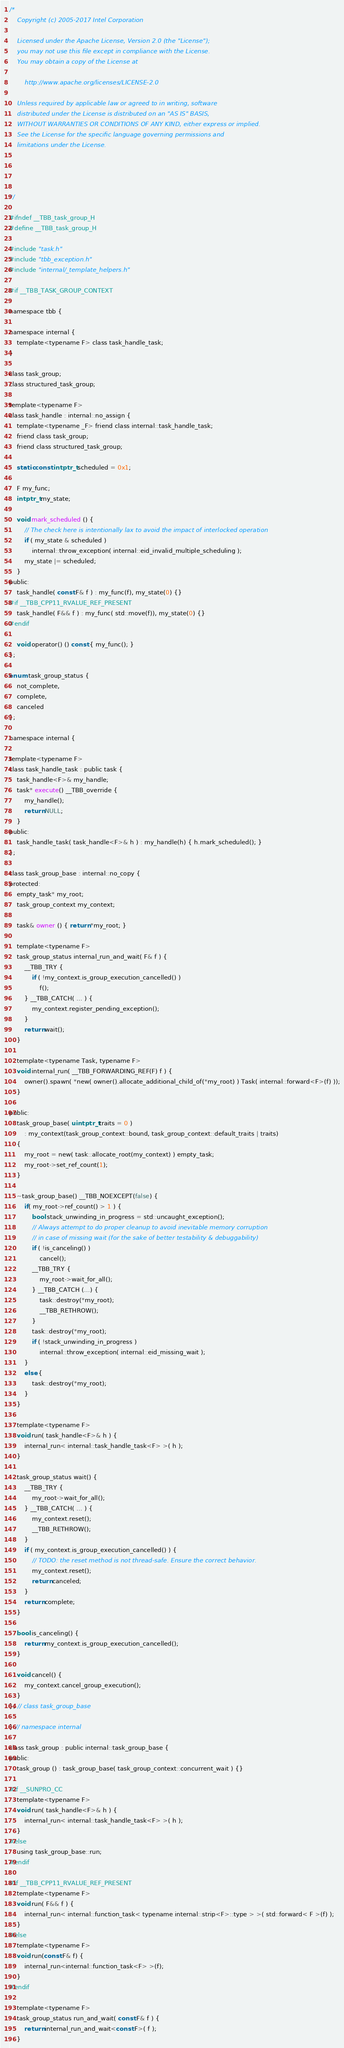Convert code to text. <code><loc_0><loc_0><loc_500><loc_500><_C_>/*
    Copyright (c) 2005-2017 Intel Corporation

    Licensed under the Apache License, Version 2.0 (the "License");
    you may not use this file except in compliance with the License.
    You may obtain a copy of the License at

        http://www.apache.org/licenses/LICENSE-2.0

    Unless required by applicable law or agreed to in writing, software
    distributed under the License is distributed on an "AS IS" BASIS,
    WITHOUT WARRANTIES OR CONDITIONS OF ANY KIND, either express or implied.
    See the License for the specific language governing permissions and
    limitations under the License.




*/

#ifndef __TBB_task_group_H
#define __TBB_task_group_H

#include "task.h"
#include "tbb_exception.h"
#include "internal/_template_helpers.h"

#if __TBB_TASK_GROUP_CONTEXT

namespace tbb {

namespace internal {
    template<typename F> class task_handle_task;
}

class task_group;
class structured_task_group;

template<typename F>
class task_handle : internal::no_assign {
    template<typename _F> friend class internal::task_handle_task;
    friend class task_group;
    friend class structured_task_group;

    static const intptr_t scheduled = 0x1;

    F my_func;
    intptr_t my_state;

    void mark_scheduled () {
        // The check here is intentionally lax to avoid the impact of interlocked operation
        if ( my_state & scheduled )
            internal::throw_exception( internal::eid_invalid_multiple_scheduling );
        my_state |= scheduled;
    }
public:
    task_handle( const F& f ) : my_func(f), my_state(0) {}
#if __TBB_CPP11_RVALUE_REF_PRESENT
    task_handle( F&& f ) : my_func( std::move(f)), my_state(0) {}
#endif

    void operator() () const { my_func(); }
};

enum task_group_status {
    not_complete,
    complete,
    canceled
};

namespace internal {

template<typename F>
class task_handle_task : public task {
    task_handle<F>& my_handle;
    task* execute() __TBB_override {
        my_handle();
        return NULL;
    }
public:
    task_handle_task( task_handle<F>& h ) : my_handle(h) { h.mark_scheduled(); }
};

class task_group_base : internal::no_copy {
protected:
    empty_task* my_root;
    task_group_context my_context;

    task& owner () { return *my_root; }

    template<typename F>
    task_group_status internal_run_and_wait( F& f ) {
        __TBB_TRY {
            if ( !my_context.is_group_execution_cancelled() )
                f();
        } __TBB_CATCH( ... ) {
            my_context.register_pending_exception();
        }
        return wait();
    }

    template<typename Task, typename F>
    void internal_run( __TBB_FORWARDING_REF(F) f ) {
        owner().spawn( *new( owner().allocate_additional_child_of(*my_root) ) Task( internal::forward<F>(f) ));
    }

public:
    task_group_base( uintptr_t traits = 0 )
        : my_context(task_group_context::bound, task_group_context::default_traits | traits)
    {
        my_root = new( task::allocate_root(my_context) ) empty_task;
        my_root->set_ref_count(1);
    }

    ~task_group_base() __TBB_NOEXCEPT(false) {
        if( my_root->ref_count() > 1 ) {
            bool stack_unwinding_in_progress = std::uncaught_exception();
            // Always attempt to do proper cleanup to avoid inevitable memory corruption
            // in case of missing wait (for the sake of better testability & debuggability)
            if ( !is_canceling() )
                cancel();
            __TBB_TRY {
                my_root->wait_for_all();
            } __TBB_CATCH (...) {
                task::destroy(*my_root);
                __TBB_RETHROW();
            }
            task::destroy(*my_root);
            if ( !stack_unwinding_in_progress )
                internal::throw_exception( internal::eid_missing_wait );
        }
        else {
            task::destroy(*my_root);
        }
    }

    template<typename F>
    void run( task_handle<F>& h ) {
        internal_run< internal::task_handle_task<F> >( h );
    }

    task_group_status wait() {
        __TBB_TRY {
            my_root->wait_for_all();
        } __TBB_CATCH( ... ) {
            my_context.reset();
            __TBB_RETHROW();
        }
        if ( my_context.is_group_execution_cancelled() ) {
            // TODO: the reset method is not thread-safe. Ensure the correct behavior.
            my_context.reset();
            return canceled;
        }
        return complete;
    }

    bool is_canceling() {
        return my_context.is_group_execution_cancelled();
    }

    void cancel() {
        my_context.cancel_group_execution();
    }
}; // class task_group_base

} // namespace internal

class task_group : public internal::task_group_base {
public:
    task_group () : task_group_base( task_group_context::concurrent_wait ) {}

#if __SUNPRO_CC
    template<typename F>
    void run( task_handle<F>& h ) {
        internal_run< internal::task_handle_task<F> >( h );
    }
#else
    using task_group_base::run;
#endif

#if __TBB_CPP11_RVALUE_REF_PRESENT
    template<typename F>
    void run( F&& f ) {
        internal_run< internal::function_task< typename internal::strip<F>::type > >( std::forward< F >(f) );
    }
#else
    template<typename F>
    void run(const F& f) {
        internal_run<internal::function_task<F> >(f);
    }
#endif

    template<typename F>
    task_group_status run_and_wait( const F& f ) {
        return internal_run_and_wait<const F>( f );
    }
</code> 